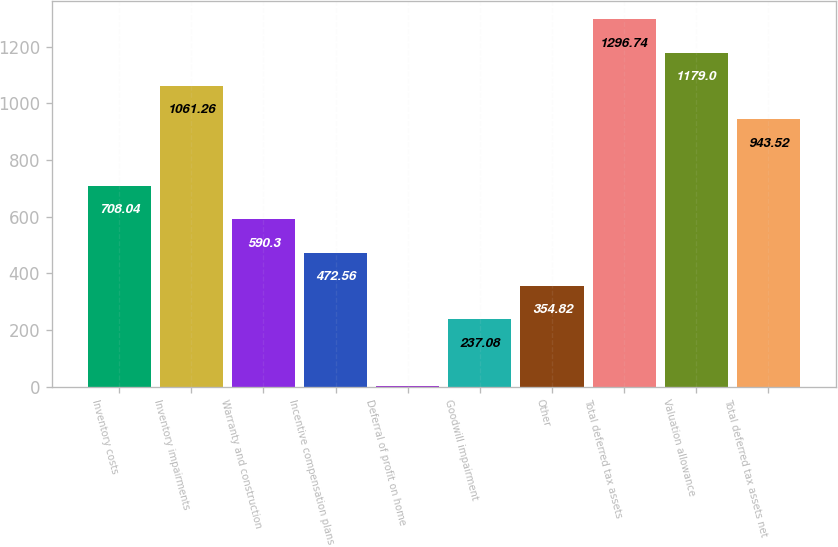<chart> <loc_0><loc_0><loc_500><loc_500><bar_chart><fcel>Inventory costs<fcel>Inventory impairments<fcel>Warranty and construction<fcel>Incentive compensation plans<fcel>Deferral of profit on home<fcel>Goodwill impairment<fcel>Other<fcel>Total deferred tax assets<fcel>Valuation allowance<fcel>Total deferred tax assets net<nl><fcel>708.04<fcel>1061.26<fcel>590.3<fcel>472.56<fcel>1.6<fcel>237.08<fcel>354.82<fcel>1296.74<fcel>1179<fcel>943.52<nl></chart> 